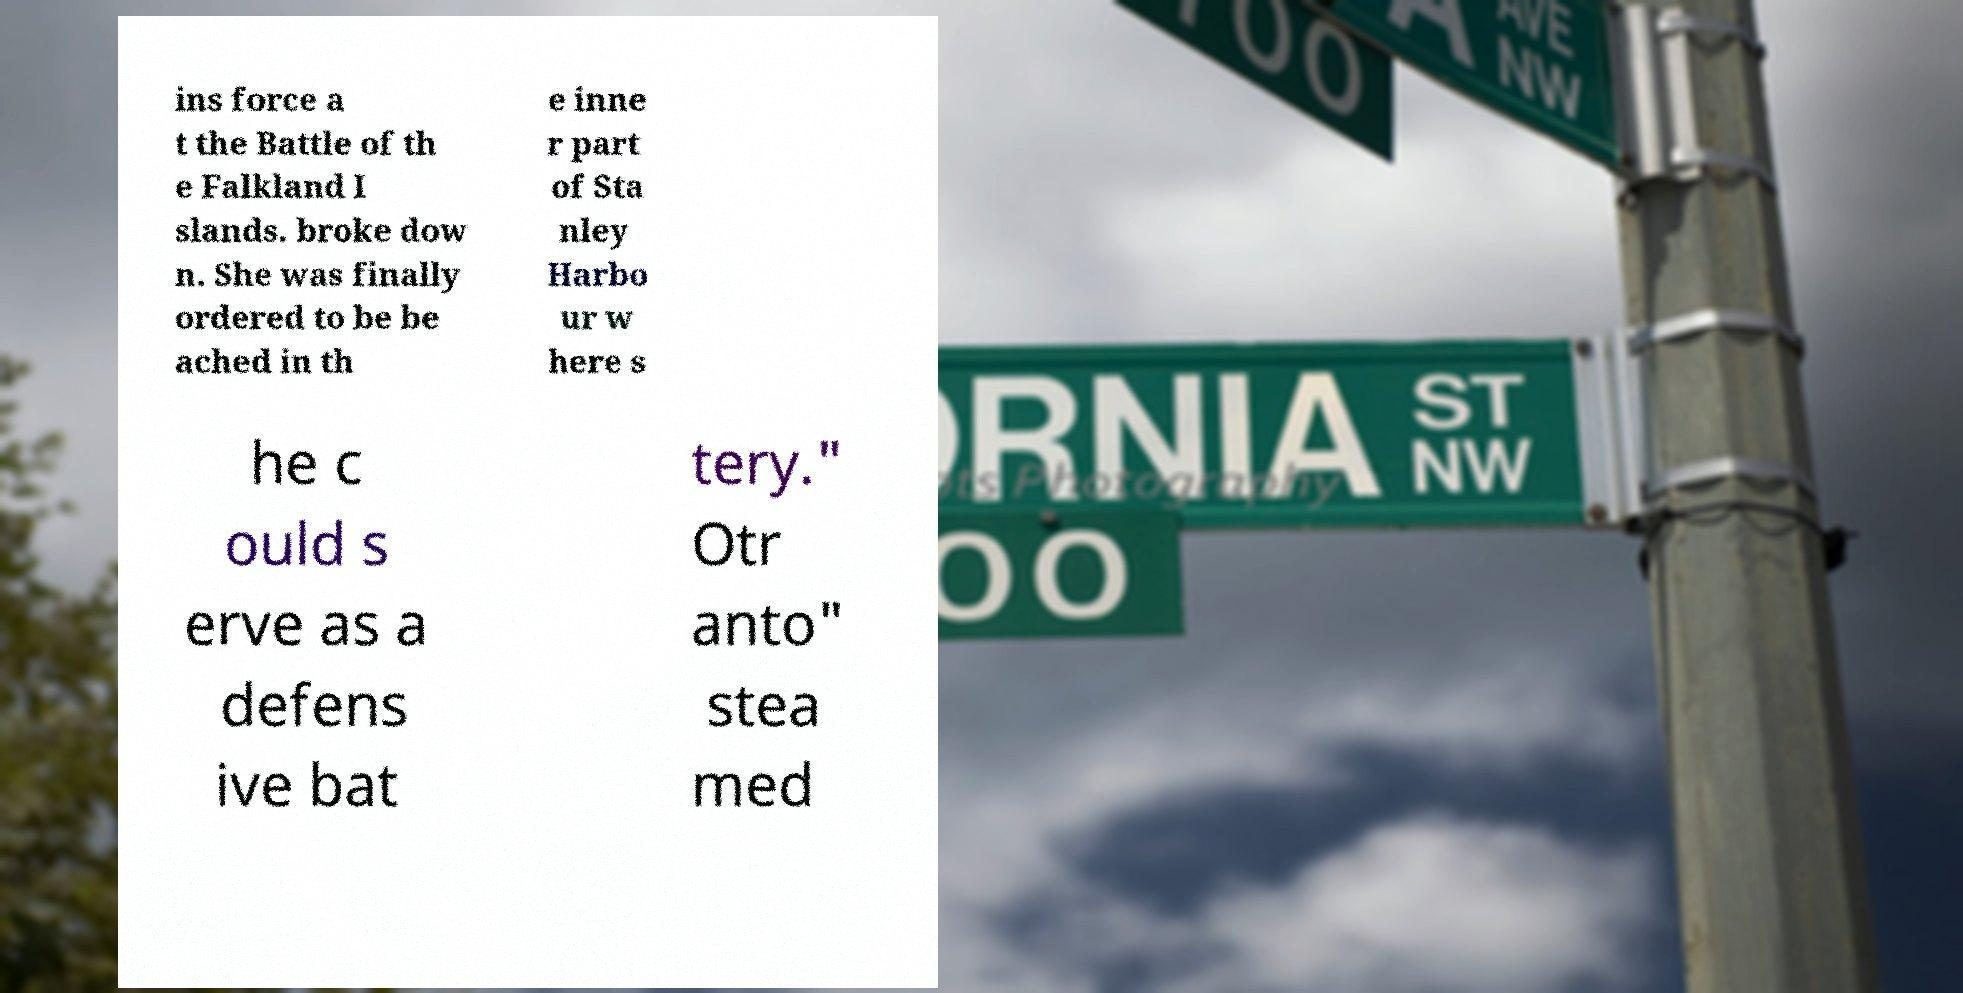What messages or text are displayed in this image? I need them in a readable, typed format. ins force a t the Battle of th e Falkland I slands. broke dow n. She was finally ordered to be be ached in th e inne r part of Sta nley Harbo ur w here s he c ould s erve as a defens ive bat tery." Otr anto" stea med 